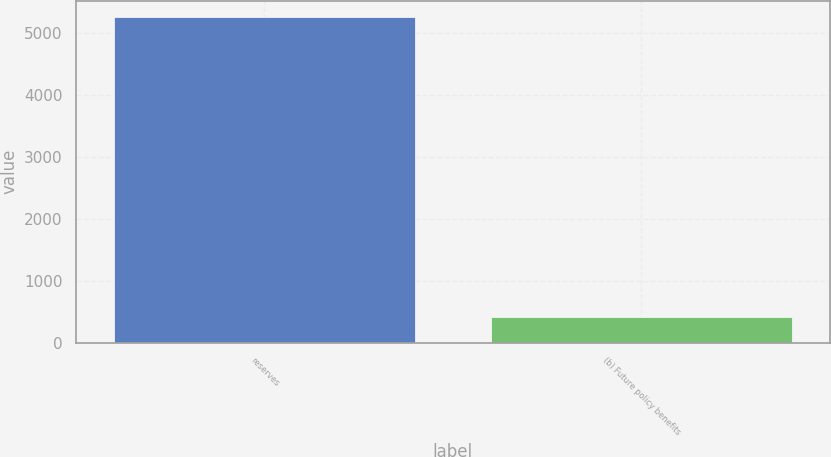Convert chart. <chart><loc_0><loc_0><loc_500><loc_500><bar_chart><fcel>reserves<fcel>(b) Future policy benefits<nl><fcel>5256<fcel>420<nl></chart> 